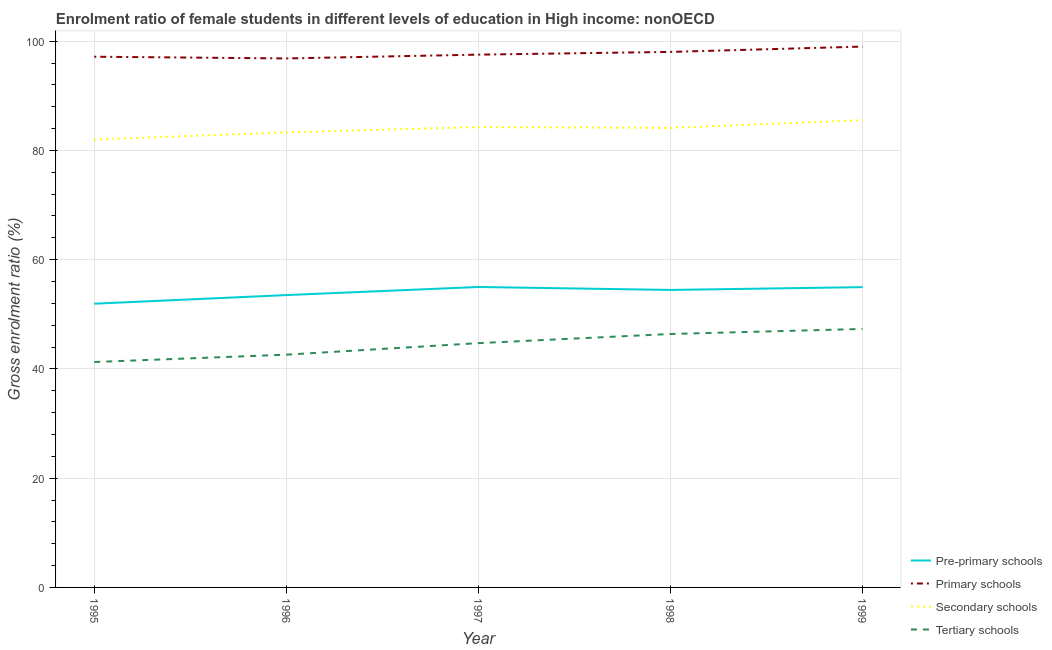Is the number of lines equal to the number of legend labels?
Offer a very short reply. Yes. What is the gross enrolment ratio(male) in primary schools in 1996?
Ensure brevity in your answer.  96.84. Across all years, what is the maximum gross enrolment ratio(male) in tertiary schools?
Keep it short and to the point. 47.32. Across all years, what is the minimum gross enrolment ratio(male) in tertiary schools?
Ensure brevity in your answer.  41.27. In which year was the gross enrolment ratio(male) in tertiary schools maximum?
Offer a very short reply. 1999. What is the total gross enrolment ratio(male) in pre-primary schools in the graph?
Give a very brief answer. 269.9. What is the difference between the gross enrolment ratio(male) in secondary schools in 1995 and that in 1996?
Your answer should be compact. -1.3. What is the difference between the gross enrolment ratio(male) in primary schools in 1997 and the gross enrolment ratio(male) in tertiary schools in 1996?
Offer a very short reply. 54.93. What is the average gross enrolment ratio(male) in pre-primary schools per year?
Provide a succinct answer. 53.98. In the year 1997, what is the difference between the gross enrolment ratio(male) in primary schools and gross enrolment ratio(male) in tertiary schools?
Offer a terse response. 52.82. In how many years, is the gross enrolment ratio(male) in tertiary schools greater than 68 %?
Your answer should be compact. 0. What is the ratio of the gross enrolment ratio(male) in tertiary schools in 1996 to that in 1998?
Your answer should be very brief. 0.92. Is the gross enrolment ratio(male) in primary schools in 1995 less than that in 1998?
Make the answer very short. Yes. Is the difference between the gross enrolment ratio(male) in secondary schools in 1996 and 1999 greater than the difference between the gross enrolment ratio(male) in primary schools in 1996 and 1999?
Keep it short and to the point. No. What is the difference between the highest and the second highest gross enrolment ratio(male) in primary schools?
Your answer should be very brief. 0.97. What is the difference between the highest and the lowest gross enrolment ratio(male) in secondary schools?
Offer a very short reply. 3.53. In how many years, is the gross enrolment ratio(male) in secondary schools greater than the average gross enrolment ratio(male) in secondary schools taken over all years?
Give a very brief answer. 3. Is the sum of the gross enrolment ratio(male) in tertiary schools in 1995 and 1997 greater than the maximum gross enrolment ratio(male) in secondary schools across all years?
Your answer should be very brief. Yes. Is it the case that in every year, the sum of the gross enrolment ratio(male) in secondary schools and gross enrolment ratio(male) in tertiary schools is greater than the sum of gross enrolment ratio(male) in pre-primary schools and gross enrolment ratio(male) in primary schools?
Your answer should be very brief. No. Is the gross enrolment ratio(male) in pre-primary schools strictly greater than the gross enrolment ratio(male) in tertiary schools over the years?
Provide a succinct answer. Yes. Is the gross enrolment ratio(male) in primary schools strictly less than the gross enrolment ratio(male) in tertiary schools over the years?
Provide a short and direct response. No. How many years are there in the graph?
Offer a very short reply. 5. Does the graph contain any zero values?
Provide a short and direct response. No. Does the graph contain grids?
Your answer should be compact. Yes. Where does the legend appear in the graph?
Ensure brevity in your answer.  Bottom right. How many legend labels are there?
Provide a succinct answer. 4. What is the title of the graph?
Keep it short and to the point. Enrolment ratio of female students in different levels of education in High income: nonOECD. What is the Gross enrolment ratio (%) in Pre-primary schools in 1995?
Ensure brevity in your answer.  51.94. What is the Gross enrolment ratio (%) of Primary schools in 1995?
Offer a terse response. 97.16. What is the Gross enrolment ratio (%) of Secondary schools in 1995?
Provide a succinct answer. 82. What is the Gross enrolment ratio (%) of Tertiary schools in 1995?
Offer a very short reply. 41.27. What is the Gross enrolment ratio (%) of Pre-primary schools in 1996?
Your answer should be compact. 53.52. What is the Gross enrolment ratio (%) in Primary schools in 1996?
Offer a terse response. 96.84. What is the Gross enrolment ratio (%) of Secondary schools in 1996?
Make the answer very short. 83.3. What is the Gross enrolment ratio (%) in Tertiary schools in 1996?
Offer a terse response. 42.61. What is the Gross enrolment ratio (%) of Pre-primary schools in 1997?
Offer a terse response. 55. What is the Gross enrolment ratio (%) in Primary schools in 1997?
Offer a terse response. 97.54. What is the Gross enrolment ratio (%) of Secondary schools in 1997?
Offer a terse response. 84.29. What is the Gross enrolment ratio (%) in Tertiary schools in 1997?
Make the answer very short. 44.72. What is the Gross enrolment ratio (%) of Pre-primary schools in 1998?
Offer a terse response. 54.46. What is the Gross enrolment ratio (%) of Primary schools in 1998?
Keep it short and to the point. 98.04. What is the Gross enrolment ratio (%) of Secondary schools in 1998?
Provide a short and direct response. 84.12. What is the Gross enrolment ratio (%) of Tertiary schools in 1998?
Ensure brevity in your answer.  46.4. What is the Gross enrolment ratio (%) in Pre-primary schools in 1999?
Your answer should be very brief. 54.98. What is the Gross enrolment ratio (%) in Primary schools in 1999?
Your answer should be compact. 99.01. What is the Gross enrolment ratio (%) in Secondary schools in 1999?
Give a very brief answer. 85.54. What is the Gross enrolment ratio (%) in Tertiary schools in 1999?
Your answer should be compact. 47.32. Across all years, what is the maximum Gross enrolment ratio (%) in Pre-primary schools?
Offer a terse response. 55. Across all years, what is the maximum Gross enrolment ratio (%) of Primary schools?
Give a very brief answer. 99.01. Across all years, what is the maximum Gross enrolment ratio (%) in Secondary schools?
Your answer should be very brief. 85.54. Across all years, what is the maximum Gross enrolment ratio (%) in Tertiary schools?
Offer a terse response. 47.32. Across all years, what is the minimum Gross enrolment ratio (%) of Pre-primary schools?
Provide a short and direct response. 51.94. Across all years, what is the minimum Gross enrolment ratio (%) in Primary schools?
Ensure brevity in your answer.  96.84. Across all years, what is the minimum Gross enrolment ratio (%) of Secondary schools?
Provide a short and direct response. 82. Across all years, what is the minimum Gross enrolment ratio (%) of Tertiary schools?
Your answer should be compact. 41.27. What is the total Gross enrolment ratio (%) in Pre-primary schools in the graph?
Make the answer very short. 269.9. What is the total Gross enrolment ratio (%) of Primary schools in the graph?
Your answer should be compact. 488.59. What is the total Gross enrolment ratio (%) in Secondary schools in the graph?
Ensure brevity in your answer.  419.25. What is the total Gross enrolment ratio (%) of Tertiary schools in the graph?
Offer a very short reply. 222.32. What is the difference between the Gross enrolment ratio (%) of Pre-primary schools in 1995 and that in 1996?
Give a very brief answer. -1.58. What is the difference between the Gross enrolment ratio (%) of Primary schools in 1995 and that in 1996?
Keep it short and to the point. 0.32. What is the difference between the Gross enrolment ratio (%) in Secondary schools in 1995 and that in 1996?
Your answer should be very brief. -1.3. What is the difference between the Gross enrolment ratio (%) in Tertiary schools in 1995 and that in 1996?
Your answer should be very brief. -1.34. What is the difference between the Gross enrolment ratio (%) of Pre-primary schools in 1995 and that in 1997?
Keep it short and to the point. -3.06. What is the difference between the Gross enrolment ratio (%) of Primary schools in 1995 and that in 1997?
Your answer should be very brief. -0.38. What is the difference between the Gross enrolment ratio (%) in Secondary schools in 1995 and that in 1997?
Give a very brief answer. -2.29. What is the difference between the Gross enrolment ratio (%) of Tertiary schools in 1995 and that in 1997?
Make the answer very short. -3.45. What is the difference between the Gross enrolment ratio (%) in Pre-primary schools in 1995 and that in 1998?
Provide a succinct answer. -2.52. What is the difference between the Gross enrolment ratio (%) of Primary schools in 1995 and that in 1998?
Your answer should be compact. -0.88. What is the difference between the Gross enrolment ratio (%) in Secondary schools in 1995 and that in 1998?
Your answer should be compact. -2.12. What is the difference between the Gross enrolment ratio (%) in Tertiary schools in 1995 and that in 1998?
Your answer should be very brief. -5.13. What is the difference between the Gross enrolment ratio (%) in Pre-primary schools in 1995 and that in 1999?
Your response must be concise. -3.03. What is the difference between the Gross enrolment ratio (%) in Primary schools in 1995 and that in 1999?
Your answer should be compact. -1.85. What is the difference between the Gross enrolment ratio (%) in Secondary schools in 1995 and that in 1999?
Your answer should be very brief. -3.53. What is the difference between the Gross enrolment ratio (%) in Tertiary schools in 1995 and that in 1999?
Offer a terse response. -6.05. What is the difference between the Gross enrolment ratio (%) in Pre-primary schools in 1996 and that in 1997?
Your answer should be compact. -1.48. What is the difference between the Gross enrolment ratio (%) in Primary schools in 1996 and that in 1997?
Provide a short and direct response. -0.7. What is the difference between the Gross enrolment ratio (%) in Secondary schools in 1996 and that in 1997?
Your response must be concise. -0.99. What is the difference between the Gross enrolment ratio (%) in Tertiary schools in 1996 and that in 1997?
Offer a very short reply. -2.11. What is the difference between the Gross enrolment ratio (%) in Pre-primary schools in 1996 and that in 1998?
Your answer should be compact. -0.94. What is the difference between the Gross enrolment ratio (%) in Primary schools in 1996 and that in 1998?
Make the answer very short. -1.2. What is the difference between the Gross enrolment ratio (%) in Secondary schools in 1996 and that in 1998?
Your answer should be very brief. -0.82. What is the difference between the Gross enrolment ratio (%) of Tertiary schools in 1996 and that in 1998?
Your response must be concise. -3.79. What is the difference between the Gross enrolment ratio (%) in Pre-primary schools in 1996 and that in 1999?
Your answer should be very brief. -1.45. What is the difference between the Gross enrolment ratio (%) in Primary schools in 1996 and that in 1999?
Your answer should be compact. -2.17. What is the difference between the Gross enrolment ratio (%) in Secondary schools in 1996 and that in 1999?
Make the answer very short. -2.24. What is the difference between the Gross enrolment ratio (%) in Tertiary schools in 1996 and that in 1999?
Your answer should be compact. -4.71. What is the difference between the Gross enrolment ratio (%) of Pre-primary schools in 1997 and that in 1998?
Your answer should be compact. 0.54. What is the difference between the Gross enrolment ratio (%) of Primary schools in 1997 and that in 1998?
Your response must be concise. -0.5. What is the difference between the Gross enrolment ratio (%) in Secondary schools in 1997 and that in 1998?
Make the answer very short. 0.16. What is the difference between the Gross enrolment ratio (%) in Tertiary schools in 1997 and that in 1998?
Ensure brevity in your answer.  -1.68. What is the difference between the Gross enrolment ratio (%) of Pre-primary schools in 1997 and that in 1999?
Your response must be concise. 0.03. What is the difference between the Gross enrolment ratio (%) in Primary schools in 1997 and that in 1999?
Give a very brief answer. -1.47. What is the difference between the Gross enrolment ratio (%) in Secondary schools in 1997 and that in 1999?
Your response must be concise. -1.25. What is the difference between the Gross enrolment ratio (%) in Tertiary schools in 1997 and that in 1999?
Your answer should be compact. -2.6. What is the difference between the Gross enrolment ratio (%) of Pre-primary schools in 1998 and that in 1999?
Provide a short and direct response. -0.51. What is the difference between the Gross enrolment ratio (%) of Primary schools in 1998 and that in 1999?
Your answer should be very brief. -0.97. What is the difference between the Gross enrolment ratio (%) in Secondary schools in 1998 and that in 1999?
Your answer should be compact. -1.41. What is the difference between the Gross enrolment ratio (%) in Tertiary schools in 1998 and that in 1999?
Provide a succinct answer. -0.92. What is the difference between the Gross enrolment ratio (%) in Pre-primary schools in 1995 and the Gross enrolment ratio (%) in Primary schools in 1996?
Offer a very short reply. -44.9. What is the difference between the Gross enrolment ratio (%) of Pre-primary schools in 1995 and the Gross enrolment ratio (%) of Secondary schools in 1996?
Give a very brief answer. -31.36. What is the difference between the Gross enrolment ratio (%) of Pre-primary schools in 1995 and the Gross enrolment ratio (%) of Tertiary schools in 1996?
Ensure brevity in your answer.  9.33. What is the difference between the Gross enrolment ratio (%) of Primary schools in 1995 and the Gross enrolment ratio (%) of Secondary schools in 1996?
Offer a terse response. 13.86. What is the difference between the Gross enrolment ratio (%) of Primary schools in 1995 and the Gross enrolment ratio (%) of Tertiary schools in 1996?
Your answer should be compact. 54.55. What is the difference between the Gross enrolment ratio (%) of Secondary schools in 1995 and the Gross enrolment ratio (%) of Tertiary schools in 1996?
Provide a short and direct response. 39.39. What is the difference between the Gross enrolment ratio (%) in Pre-primary schools in 1995 and the Gross enrolment ratio (%) in Primary schools in 1997?
Make the answer very short. -45.6. What is the difference between the Gross enrolment ratio (%) of Pre-primary schools in 1995 and the Gross enrolment ratio (%) of Secondary schools in 1997?
Your answer should be very brief. -32.35. What is the difference between the Gross enrolment ratio (%) in Pre-primary schools in 1995 and the Gross enrolment ratio (%) in Tertiary schools in 1997?
Provide a succinct answer. 7.22. What is the difference between the Gross enrolment ratio (%) in Primary schools in 1995 and the Gross enrolment ratio (%) in Secondary schools in 1997?
Your response must be concise. 12.87. What is the difference between the Gross enrolment ratio (%) of Primary schools in 1995 and the Gross enrolment ratio (%) of Tertiary schools in 1997?
Your answer should be very brief. 52.44. What is the difference between the Gross enrolment ratio (%) of Secondary schools in 1995 and the Gross enrolment ratio (%) of Tertiary schools in 1997?
Ensure brevity in your answer.  37.28. What is the difference between the Gross enrolment ratio (%) of Pre-primary schools in 1995 and the Gross enrolment ratio (%) of Primary schools in 1998?
Offer a very short reply. -46.1. What is the difference between the Gross enrolment ratio (%) in Pre-primary schools in 1995 and the Gross enrolment ratio (%) in Secondary schools in 1998?
Your answer should be compact. -32.18. What is the difference between the Gross enrolment ratio (%) in Pre-primary schools in 1995 and the Gross enrolment ratio (%) in Tertiary schools in 1998?
Offer a terse response. 5.54. What is the difference between the Gross enrolment ratio (%) in Primary schools in 1995 and the Gross enrolment ratio (%) in Secondary schools in 1998?
Your response must be concise. 13.03. What is the difference between the Gross enrolment ratio (%) of Primary schools in 1995 and the Gross enrolment ratio (%) of Tertiary schools in 1998?
Offer a terse response. 50.76. What is the difference between the Gross enrolment ratio (%) in Secondary schools in 1995 and the Gross enrolment ratio (%) in Tertiary schools in 1998?
Give a very brief answer. 35.6. What is the difference between the Gross enrolment ratio (%) in Pre-primary schools in 1995 and the Gross enrolment ratio (%) in Primary schools in 1999?
Provide a succinct answer. -47.07. What is the difference between the Gross enrolment ratio (%) in Pre-primary schools in 1995 and the Gross enrolment ratio (%) in Secondary schools in 1999?
Your response must be concise. -33.6. What is the difference between the Gross enrolment ratio (%) in Pre-primary schools in 1995 and the Gross enrolment ratio (%) in Tertiary schools in 1999?
Your response must be concise. 4.62. What is the difference between the Gross enrolment ratio (%) of Primary schools in 1995 and the Gross enrolment ratio (%) of Secondary schools in 1999?
Your response must be concise. 11.62. What is the difference between the Gross enrolment ratio (%) in Primary schools in 1995 and the Gross enrolment ratio (%) in Tertiary schools in 1999?
Your answer should be very brief. 49.84. What is the difference between the Gross enrolment ratio (%) of Secondary schools in 1995 and the Gross enrolment ratio (%) of Tertiary schools in 1999?
Give a very brief answer. 34.68. What is the difference between the Gross enrolment ratio (%) of Pre-primary schools in 1996 and the Gross enrolment ratio (%) of Primary schools in 1997?
Provide a succinct answer. -44.02. What is the difference between the Gross enrolment ratio (%) of Pre-primary schools in 1996 and the Gross enrolment ratio (%) of Secondary schools in 1997?
Your response must be concise. -30.77. What is the difference between the Gross enrolment ratio (%) in Pre-primary schools in 1996 and the Gross enrolment ratio (%) in Tertiary schools in 1997?
Keep it short and to the point. 8.8. What is the difference between the Gross enrolment ratio (%) of Primary schools in 1996 and the Gross enrolment ratio (%) of Secondary schools in 1997?
Keep it short and to the point. 12.55. What is the difference between the Gross enrolment ratio (%) in Primary schools in 1996 and the Gross enrolment ratio (%) in Tertiary schools in 1997?
Provide a short and direct response. 52.12. What is the difference between the Gross enrolment ratio (%) in Secondary schools in 1996 and the Gross enrolment ratio (%) in Tertiary schools in 1997?
Ensure brevity in your answer.  38.58. What is the difference between the Gross enrolment ratio (%) in Pre-primary schools in 1996 and the Gross enrolment ratio (%) in Primary schools in 1998?
Your response must be concise. -44.52. What is the difference between the Gross enrolment ratio (%) in Pre-primary schools in 1996 and the Gross enrolment ratio (%) in Secondary schools in 1998?
Offer a very short reply. -30.6. What is the difference between the Gross enrolment ratio (%) in Pre-primary schools in 1996 and the Gross enrolment ratio (%) in Tertiary schools in 1998?
Provide a succinct answer. 7.12. What is the difference between the Gross enrolment ratio (%) of Primary schools in 1996 and the Gross enrolment ratio (%) of Secondary schools in 1998?
Provide a succinct answer. 12.72. What is the difference between the Gross enrolment ratio (%) of Primary schools in 1996 and the Gross enrolment ratio (%) of Tertiary schools in 1998?
Keep it short and to the point. 50.44. What is the difference between the Gross enrolment ratio (%) of Secondary schools in 1996 and the Gross enrolment ratio (%) of Tertiary schools in 1998?
Offer a very short reply. 36.9. What is the difference between the Gross enrolment ratio (%) of Pre-primary schools in 1996 and the Gross enrolment ratio (%) of Primary schools in 1999?
Offer a very short reply. -45.49. What is the difference between the Gross enrolment ratio (%) of Pre-primary schools in 1996 and the Gross enrolment ratio (%) of Secondary schools in 1999?
Provide a succinct answer. -32.02. What is the difference between the Gross enrolment ratio (%) of Pre-primary schools in 1996 and the Gross enrolment ratio (%) of Tertiary schools in 1999?
Offer a terse response. 6.2. What is the difference between the Gross enrolment ratio (%) of Primary schools in 1996 and the Gross enrolment ratio (%) of Secondary schools in 1999?
Offer a terse response. 11.31. What is the difference between the Gross enrolment ratio (%) of Primary schools in 1996 and the Gross enrolment ratio (%) of Tertiary schools in 1999?
Provide a short and direct response. 49.52. What is the difference between the Gross enrolment ratio (%) of Secondary schools in 1996 and the Gross enrolment ratio (%) of Tertiary schools in 1999?
Provide a short and direct response. 35.98. What is the difference between the Gross enrolment ratio (%) of Pre-primary schools in 1997 and the Gross enrolment ratio (%) of Primary schools in 1998?
Your answer should be compact. -43.04. What is the difference between the Gross enrolment ratio (%) of Pre-primary schools in 1997 and the Gross enrolment ratio (%) of Secondary schools in 1998?
Give a very brief answer. -29.12. What is the difference between the Gross enrolment ratio (%) in Pre-primary schools in 1997 and the Gross enrolment ratio (%) in Tertiary schools in 1998?
Ensure brevity in your answer.  8.6. What is the difference between the Gross enrolment ratio (%) of Primary schools in 1997 and the Gross enrolment ratio (%) of Secondary schools in 1998?
Keep it short and to the point. 13.41. What is the difference between the Gross enrolment ratio (%) of Primary schools in 1997 and the Gross enrolment ratio (%) of Tertiary schools in 1998?
Your answer should be compact. 51.14. What is the difference between the Gross enrolment ratio (%) of Secondary schools in 1997 and the Gross enrolment ratio (%) of Tertiary schools in 1998?
Ensure brevity in your answer.  37.89. What is the difference between the Gross enrolment ratio (%) in Pre-primary schools in 1997 and the Gross enrolment ratio (%) in Primary schools in 1999?
Give a very brief answer. -44.01. What is the difference between the Gross enrolment ratio (%) in Pre-primary schools in 1997 and the Gross enrolment ratio (%) in Secondary schools in 1999?
Your answer should be very brief. -30.53. What is the difference between the Gross enrolment ratio (%) in Pre-primary schools in 1997 and the Gross enrolment ratio (%) in Tertiary schools in 1999?
Offer a terse response. 7.68. What is the difference between the Gross enrolment ratio (%) in Primary schools in 1997 and the Gross enrolment ratio (%) in Secondary schools in 1999?
Your response must be concise. 12. What is the difference between the Gross enrolment ratio (%) in Primary schools in 1997 and the Gross enrolment ratio (%) in Tertiary schools in 1999?
Offer a very short reply. 50.22. What is the difference between the Gross enrolment ratio (%) of Secondary schools in 1997 and the Gross enrolment ratio (%) of Tertiary schools in 1999?
Provide a short and direct response. 36.97. What is the difference between the Gross enrolment ratio (%) of Pre-primary schools in 1998 and the Gross enrolment ratio (%) of Primary schools in 1999?
Provide a short and direct response. -44.55. What is the difference between the Gross enrolment ratio (%) in Pre-primary schools in 1998 and the Gross enrolment ratio (%) in Secondary schools in 1999?
Ensure brevity in your answer.  -31.08. What is the difference between the Gross enrolment ratio (%) of Pre-primary schools in 1998 and the Gross enrolment ratio (%) of Tertiary schools in 1999?
Give a very brief answer. 7.14. What is the difference between the Gross enrolment ratio (%) in Primary schools in 1998 and the Gross enrolment ratio (%) in Secondary schools in 1999?
Offer a terse response. 12.5. What is the difference between the Gross enrolment ratio (%) of Primary schools in 1998 and the Gross enrolment ratio (%) of Tertiary schools in 1999?
Provide a short and direct response. 50.72. What is the difference between the Gross enrolment ratio (%) in Secondary schools in 1998 and the Gross enrolment ratio (%) in Tertiary schools in 1999?
Provide a succinct answer. 36.8. What is the average Gross enrolment ratio (%) of Pre-primary schools per year?
Offer a very short reply. 53.98. What is the average Gross enrolment ratio (%) of Primary schools per year?
Keep it short and to the point. 97.72. What is the average Gross enrolment ratio (%) of Secondary schools per year?
Offer a very short reply. 83.85. What is the average Gross enrolment ratio (%) of Tertiary schools per year?
Your response must be concise. 44.46. In the year 1995, what is the difference between the Gross enrolment ratio (%) of Pre-primary schools and Gross enrolment ratio (%) of Primary schools?
Provide a succinct answer. -45.22. In the year 1995, what is the difference between the Gross enrolment ratio (%) of Pre-primary schools and Gross enrolment ratio (%) of Secondary schools?
Your answer should be compact. -30.06. In the year 1995, what is the difference between the Gross enrolment ratio (%) in Pre-primary schools and Gross enrolment ratio (%) in Tertiary schools?
Your response must be concise. 10.67. In the year 1995, what is the difference between the Gross enrolment ratio (%) in Primary schools and Gross enrolment ratio (%) in Secondary schools?
Your answer should be compact. 15.16. In the year 1995, what is the difference between the Gross enrolment ratio (%) of Primary schools and Gross enrolment ratio (%) of Tertiary schools?
Your answer should be very brief. 55.89. In the year 1995, what is the difference between the Gross enrolment ratio (%) of Secondary schools and Gross enrolment ratio (%) of Tertiary schools?
Offer a very short reply. 40.73. In the year 1996, what is the difference between the Gross enrolment ratio (%) in Pre-primary schools and Gross enrolment ratio (%) in Primary schools?
Your answer should be compact. -43.32. In the year 1996, what is the difference between the Gross enrolment ratio (%) of Pre-primary schools and Gross enrolment ratio (%) of Secondary schools?
Your answer should be very brief. -29.78. In the year 1996, what is the difference between the Gross enrolment ratio (%) of Pre-primary schools and Gross enrolment ratio (%) of Tertiary schools?
Your answer should be compact. 10.91. In the year 1996, what is the difference between the Gross enrolment ratio (%) in Primary schools and Gross enrolment ratio (%) in Secondary schools?
Ensure brevity in your answer.  13.54. In the year 1996, what is the difference between the Gross enrolment ratio (%) in Primary schools and Gross enrolment ratio (%) in Tertiary schools?
Provide a short and direct response. 54.23. In the year 1996, what is the difference between the Gross enrolment ratio (%) of Secondary schools and Gross enrolment ratio (%) of Tertiary schools?
Ensure brevity in your answer.  40.69. In the year 1997, what is the difference between the Gross enrolment ratio (%) in Pre-primary schools and Gross enrolment ratio (%) in Primary schools?
Your answer should be very brief. -42.54. In the year 1997, what is the difference between the Gross enrolment ratio (%) in Pre-primary schools and Gross enrolment ratio (%) in Secondary schools?
Give a very brief answer. -29.29. In the year 1997, what is the difference between the Gross enrolment ratio (%) of Pre-primary schools and Gross enrolment ratio (%) of Tertiary schools?
Make the answer very short. 10.28. In the year 1997, what is the difference between the Gross enrolment ratio (%) of Primary schools and Gross enrolment ratio (%) of Secondary schools?
Provide a succinct answer. 13.25. In the year 1997, what is the difference between the Gross enrolment ratio (%) in Primary schools and Gross enrolment ratio (%) in Tertiary schools?
Your response must be concise. 52.82. In the year 1997, what is the difference between the Gross enrolment ratio (%) in Secondary schools and Gross enrolment ratio (%) in Tertiary schools?
Make the answer very short. 39.57. In the year 1998, what is the difference between the Gross enrolment ratio (%) in Pre-primary schools and Gross enrolment ratio (%) in Primary schools?
Keep it short and to the point. -43.58. In the year 1998, what is the difference between the Gross enrolment ratio (%) of Pre-primary schools and Gross enrolment ratio (%) of Secondary schools?
Ensure brevity in your answer.  -29.66. In the year 1998, what is the difference between the Gross enrolment ratio (%) of Pre-primary schools and Gross enrolment ratio (%) of Tertiary schools?
Ensure brevity in your answer.  8.06. In the year 1998, what is the difference between the Gross enrolment ratio (%) of Primary schools and Gross enrolment ratio (%) of Secondary schools?
Your answer should be very brief. 13.92. In the year 1998, what is the difference between the Gross enrolment ratio (%) of Primary schools and Gross enrolment ratio (%) of Tertiary schools?
Keep it short and to the point. 51.64. In the year 1998, what is the difference between the Gross enrolment ratio (%) of Secondary schools and Gross enrolment ratio (%) of Tertiary schools?
Offer a very short reply. 37.73. In the year 1999, what is the difference between the Gross enrolment ratio (%) in Pre-primary schools and Gross enrolment ratio (%) in Primary schools?
Your answer should be very brief. -44.04. In the year 1999, what is the difference between the Gross enrolment ratio (%) of Pre-primary schools and Gross enrolment ratio (%) of Secondary schools?
Provide a succinct answer. -30.56. In the year 1999, what is the difference between the Gross enrolment ratio (%) of Pre-primary schools and Gross enrolment ratio (%) of Tertiary schools?
Offer a terse response. 7.65. In the year 1999, what is the difference between the Gross enrolment ratio (%) in Primary schools and Gross enrolment ratio (%) in Secondary schools?
Offer a very short reply. 13.47. In the year 1999, what is the difference between the Gross enrolment ratio (%) in Primary schools and Gross enrolment ratio (%) in Tertiary schools?
Your answer should be very brief. 51.69. In the year 1999, what is the difference between the Gross enrolment ratio (%) of Secondary schools and Gross enrolment ratio (%) of Tertiary schools?
Provide a succinct answer. 38.21. What is the ratio of the Gross enrolment ratio (%) of Pre-primary schools in 1995 to that in 1996?
Give a very brief answer. 0.97. What is the ratio of the Gross enrolment ratio (%) of Secondary schools in 1995 to that in 1996?
Offer a very short reply. 0.98. What is the ratio of the Gross enrolment ratio (%) of Tertiary schools in 1995 to that in 1996?
Provide a short and direct response. 0.97. What is the ratio of the Gross enrolment ratio (%) of Secondary schools in 1995 to that in 1997?
Give a very brief answer. 0.97. What is the ratio of the Gross enrolment ratio (%) in Tertiary schools in 1995 to that in 1997?
Offer a terse response. 0.92. What is the ratio of the Gross enrolment ratio (%) of Pre-primary schools in 1995 to that in 1998?
Keep it short and to the point. 0.95. What is the ratio of the Gross enrolment ratio (%) of Secondary schools in 1995 to that in 1998?
Keep it short and to the point. 0.97. What is the ratio of the Gross enrolment ratio (%) of Tertiary schools in 1995 to that in 1998?
Make the answer very short. 0.89. What is the ratio of the Gross enrolment ratio (%) in Pre-primary schools in 1995 to that in 1999?
Provide a short and direct response. 0.94. What is the ratio of the Gross enrolment ratio (%) of Primary schools in 1995 to that in 1999?
Ensure brevity in your answer.  0.98. What is the ratio of the Gross enrolment ratio (%) of Secondary schools in 1995 to that in 1999?
Make the answer very short. 0.96. What is the ratio of the Gross enrolment ratio (%) in Tertiary schools in 1995 to that in 1999?
Your answer should be compact. 0.87. What is the ratio of the Gross enrolment ratio (%) in Pre-primary schools in 1996 to that in 1997?
Your answer should be compact. 0.97. What is the ratio of the Gross enrolment ratio (%) in Primary schools in 1996 to that in 1997?
Keep it short and to the point. 0.99. What is the ratio of the Gross enrolment ratio (%) in Secondary schools in 1996 to that in 1997?
Your answer should be very brief. 0.99. What is the ratio of the Gross enrolment ratio (%) in Tertiary schools in 1996 to that in 1997?
Provide a succinct answer. 0.95. What is the ratio of the Gross enrolment ratio (%) of Pre-primary schools in 1996 to that in 1998?
Provide a succinct answer. 0.98. What is the ratio of the Gross enrolment ratio (%) of Secondary schools in 1996 to that in 1998?
Make the answer very short. 0.99. What is the ratio of the Gross enrolment ratio (%) in Tertiary schools in 1996 to that in 1998?
Your answer should be compact. 0.92. What is the ratio of the Gross enrolment ratio (%) of Pre-primary schools in 1996 to that in 1999?
Provide a short and direct response. 0.97. What is the ratio of the Gross enrolment ratio (%) in Primary schools in 1996 to that in 1999?
Provide a short and direct response. 0.98. What is the ratio of the Gross enrolment ratio (%) in Secondary schools in 1996 to that in 1999?
Give a very brief answer. 0.97. What is the ratio of the Gross enrolment ratio (%) in Tertiary schools in 1996 to that in 1999?
Your response must be concise. 0.9. What is the ratio of the Gross enrolment ratio (%) of Pre-primary schools in 1997 to that in 1998?
Your response must be concise. 1.01. What is the ratio of the Gross enrolment ratio (%) of Tertiary schools in 1997 to that in 1998?
Ensure brevity in your answer.  0.96. What is the ratio of the Gross enrolment ratio (%) in Primary schools in 1997 to that in 1999?
Ensure brevity in your answer.  0.99. What is the ratio of the Gross enrolment ratio (%) of Secondary schools in 1997 to that in 1999?
Your response must be concise. 0.99. What is the ratio of the Gross enrolment ratio (%) in Tertiary schools in 1997 to that in 1999?
Ensure brevity in your answer.  0.95. What is the ratio of the Gross enrolment ratio (%) in Pre-primary schools in 1998 to that in 1999?
Your answer should be very brief. 0.99. What is the ratio of the Gross enrolment ratio (%) of Primary schools in 1998 to that in 1999?
Keep it short and to the point. 0.99. What is the ratio of the Gross enrolment ratio (%) of Secondary schools in 1998 to that in 1999?
Offer a very short reply. 0.98. What is the ratio of the Gross enrolment ratio (%) in Tertiary schools in 1998 to that in 1999?
Give a very brief answer. 0.98. What is the difference between the highest and the second highest Gross enrolment ratio (%) of Pre-primary schools?
Your response must be concise. 0.03. What is the difference between the highest and the second highest Gross enrolment ratio (%) in Primary schools?
Provide a short and direct response. 0.97. What is the difference between the highest and the second highest Gross enrolment ratio (%) of Secondary schools?
Ensure brevity in your answer.  1.25. What is the difference between the highest and the second highest Gross enrolment ratio (%) in Tertiary schools?
Your response must be concise. 0.92. What is the difference between the highest and the lowest Gross enrolment ratio (%) of Pre-primary schools?
Make the answer very short. 3.06. What is the difference between the highest and the lowest Gross enrolment ratio (%) in Primary schools?
Your response must be concise. 2.17. What is the difference between the highest and the lowest Gross enrolment ratio (%) of Secondary schools?
Offer a very short reply. 3.53. What is the difference between the highest and the lowest Gross enrolment ratio (%) of Tertiary schools?
Provide a succinct answer. 6.05. 